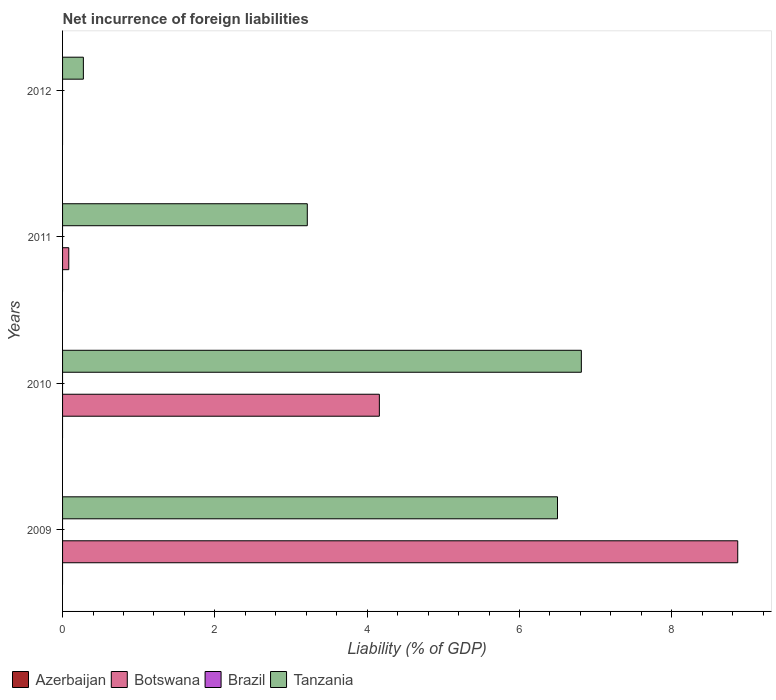How many different coloured bars are there?
Ensure brevity in your answer.  2. Are the number of bars per tick equal to the number of legend labels?
Your answer should be very brief. No. How many bars are there on the 3rd tick from the top?
Your answer should be compact. 2. How many bars are there on the 1st tick from the bottom?
Keep it short and to the point. 2. What is the net incurrence of foreign liabilities in Botswana in 2009?
Make the answer very short. 8.87. Across all years, what is the maximum net incurrence of foreign liabilities in Botswana?
Your answer should be compact. 8.87. Across all years, what is the minimum net incurrence of foreign liabilities in Azerbaijan?
Offer a very short reply. 0. In which year was the net incurrence of foreign liabilities in Botswana maximum?
Ensure brevity in your answer.  2009. What is the difference between the net incurrence of foreign liabilities in Tanzania in 2010 and that in 2012?
Make the answer very short. 6.54. What is the difference between the net incurrence of foreign liabilities in Botswana in 2010 and the net incurrence of foreign liabilities in Tanzania in 2011?
Give a very brief answer. 0.95. What is the average net incurrence of foreign liabilities in Botswana per year?
Your answer should be compact. 3.28. In the year 2010, what is the difference between the net incurrence of foreign liabilities in Botswana and net incurrence of foreign liabilities in Tanzania?
Make the answer very short. -2.65. What is the ratio of the net incurrence of foreign liabilities in Tanzania in 2010 to that in 2012?
Offer a terse response. 24.93. What is the difference between the highest and the second highest net incurrence of foreign liabilities in Botswana?
Offer a very short reply. 4.71. What is the difference between the highest and the lowest net incurrence of foreign liabilities in Tanzania?
Your answer should be very brief. 6.54. How many bars are there?
Offer a terse response. 7. Does the graph contain grids?
Your answer should be compact. No. How many legend labels are there?
Give a very brief answer. 4. How are the legend labels stacked?
Provide a succinct answer. Horizontal. What is the title of the graph?
Provide a short and direct response. Net incurrence of foreign liabilities. What is the label or title of the X-axis?
Your answer should be compact. Liability (% of GDP). What is the label or title of the Y-axis?
Your answer should be compact. Years. What is the Liability (% of GDP) in Botswana in 2009?
Provide a short and direct response. 8.87. What is the Liability (% of GDP) in Brazil in 2009?
Your response must be concise. 0. What is the Liability (% of GDP) in Tanzania in 2009?
Your answer should be very brief. 6.5. What is the Liability (% of GDP) in Botswana in 2010?
Your answer should be compact. 4.16. What is the Liability (% of GDP) of Brazil in 2010?
Your answer should be compact. 0. What is the Liability (% of GDP) in Tanzania in 2010?
Keep it short and to the point. 6.81. What is the Liability (% of GDP) of Azerbaijan in 2011?
Keep it short and to the point. 0. What is the Liability (% of GDP) in Botswana in 2011?
Provide a succinct answer. 0.08. What is the Liability (% of GDP) of Brazil in 2011?
Ensure brevity in your answer.  0. What is the Liability (% of GDP) in Tanzania in 2011?
Give a very brief answer. 3.21. What is the Liability (% of GDP) in Brazil in 2012?
Make the answer very short. 0. What is the Liability (% of GDP) in Tanzania in 2012?
Keep it short and to the point. 0.27. Across all years, what is the maximum Liability (% of GDP) in Botswana?
Give a very brief answer. 8.87. Across all years, what is the maximum Liability (% of GDP) in Tanzania?
Your answer should be very brief. 6.81. Across all years, what is the minimum Liability (% of GDP) of Botswana?
Give a very brief answer. 0. Across all years, what is the minimum Liability (% of GDP) in Tanzania?
Your answer should be compact. 0.27. What is the total Liability (% of GDP) in Azerbaijan in the graph?
Your answer should be compact. 0. What is the total Liability (% of GDP) of Botswana in the graph?
Your response must be concise. 13.11. What is the total Liability (% of GDP) in Brazil in the graph?
Provide a succinct answer. 0. What is the total Liability (% of GDP) of Tanzania in the graph?
Give a very brief answer. 16.8. What is the difference between the Liability (% of GDP) of Botswana in 2009 and that in 2010?
Your answer should be very brief. 4.71. What is the difference between the Liability (% of GDP) in Tanzania in 2009 and that in 2010?
Provide a short and direct response. -0.31. What is the difference between the Liability (% of GDP) of Botswana in 2009 and that in 2011?
Make the answer very short. 8.78. What is the difference between the Liability (% of GDP) in Tanzania in 2009 and that in 2011?
Keep it short and to the point. 3.29. What is the difference between the Liability (% of GDP) in Tanzania in 2009 and that in 2012?
Keep it short and to the point. 6.23. What is the difference between the Liability (% of GDP) in Botswana in 2010 and that in 2011?
Your answer should be compact. 4.08. What is the difference between the Liability (% of GDP) of Tanzania in 2010 and that in 2011?
Make the answer very short. 3.6. What is the difference between the Liability (% of GDP) of Tanzania in 2010 and that in 2012?
Make the answer very short. 6.54. What is the difference between the Liability (% of GDP) in Tanzania in 2011 and that in 2012?
Your answer should be compact. 2.94. What is the difference between the Liability (% of GDP) in Botswana in 2009 and the Liability (% of GDP) in Tanzania in 2010?
Provide a succinct answer. 2.05. What is the difference between the Liability (% of GDP) in Botswana in 2009 and the Liability (% of GDP) in Tanzania in 2011?
Ensure brevity in your answer.  5.65. What is the difference between the Liability (% of GDP) in Botswana in 2009 and the Liability (% of GDP) in Tanzania in 2012?
Provide a succinct answer. 8.59. What is the difference between the Liability (% of GDP) of Botswana in 2010 and the Liability (% of GDP) of Tanzania in 2011?
Your answer should be compact. 0.95. What is the difference between the Liability (% of GDP) in Botswana in 2010 and the Liability (% of GDP) in Tanzania in 2012?
Your answer should be very brief. 3.89. What is the difference between the Liability (% of GDP) of Botswana in 2011 and the Liability (% of GDP) of Tanzania in 2012?
Your response must be concise. -0.19. What is the average Liability (% of GDP) of Azerbaijan per year?
Your answer should be very brief. 0. What is the average Liability (% of GDP) of Botswana per year?
Give a very brief answer. 3.28. What is the average Liability (% of GDP) of Brazil per year?
Your response must be concise. 0. What is the average Liability (% of GDP) in Tanzania per year?
Offer a very short reply. 4.2. In the year 2009, what is the difference between the Liability (% of GDP) in Botswana and Liability (% of GDP) in Tanzania?
Ensure brevity in your answer.  2.37. In the year 2010, what is the difference between the Liability (% of GDP) of Botswana and Liability (% of GDP) of Tanzania?
Your response must be concise. -2.65. In the year 2011, what is the difference between the Liability (% of GDP) in Botswana and Liability (% of GDP) in Tanzania?
Make the answer very short. -3.13. What is the ratio of the Liability (% of GDP) of Botswana in 2009 to that in 2010?
Your answer should be compact. 2.13. What is the ratio of the Liability (% of GDP) of Tanzania in 2009 to that in 2010?
Offer a very short reply. 0.95. What is the ratio of the Liability (% of GDP) of Botswana in 2009 to that in 2011?
Make the answer very short. 108.68. What is the ratio of the Liability (% of GDP) of Tanzania in 2009 to that in 2011?
Your answer should be very brief. 2.02. What is the ratio of the Liability (% of GDP) in Tanzania in 2009 to that in 2012?
Offer a very short reply. 23.78. What is the ratio of the Liability (% of GDP) in Botswana in 2010 to that in 2011?
Give a very brief answer. 51. What is the ratio of the Liability (% of GDP) of Tanzania in 2010 to that in 2011?
Offer a very short reply. 2.12. What is the ratio of the Liability (% of GDP) in Tanzania in 2010 to that in 2012?
Your response must be concise. 24.93. What is the ratio of the Liability (% of GDP) in Tanzania in 2011 to that in 2012?
Keep it short and to the point. 11.76. What is the difference between the highest and the second highest Liability (% of GDP) of Botswana?
Offer a very short reply. 4.71. What is the difference between the highest and the second highest Liability (% of GDP) of Tanzania?
Make the answer very short. 0.31. What is the difference between the highest and the lowest Liability (% of GDP) of Botswana?
Your answer should be very brief. 8.87. What is the difference between the highest and the lowest Liability (% of GDP) of Tanzania?
Offer a very short reply. 6.54. 